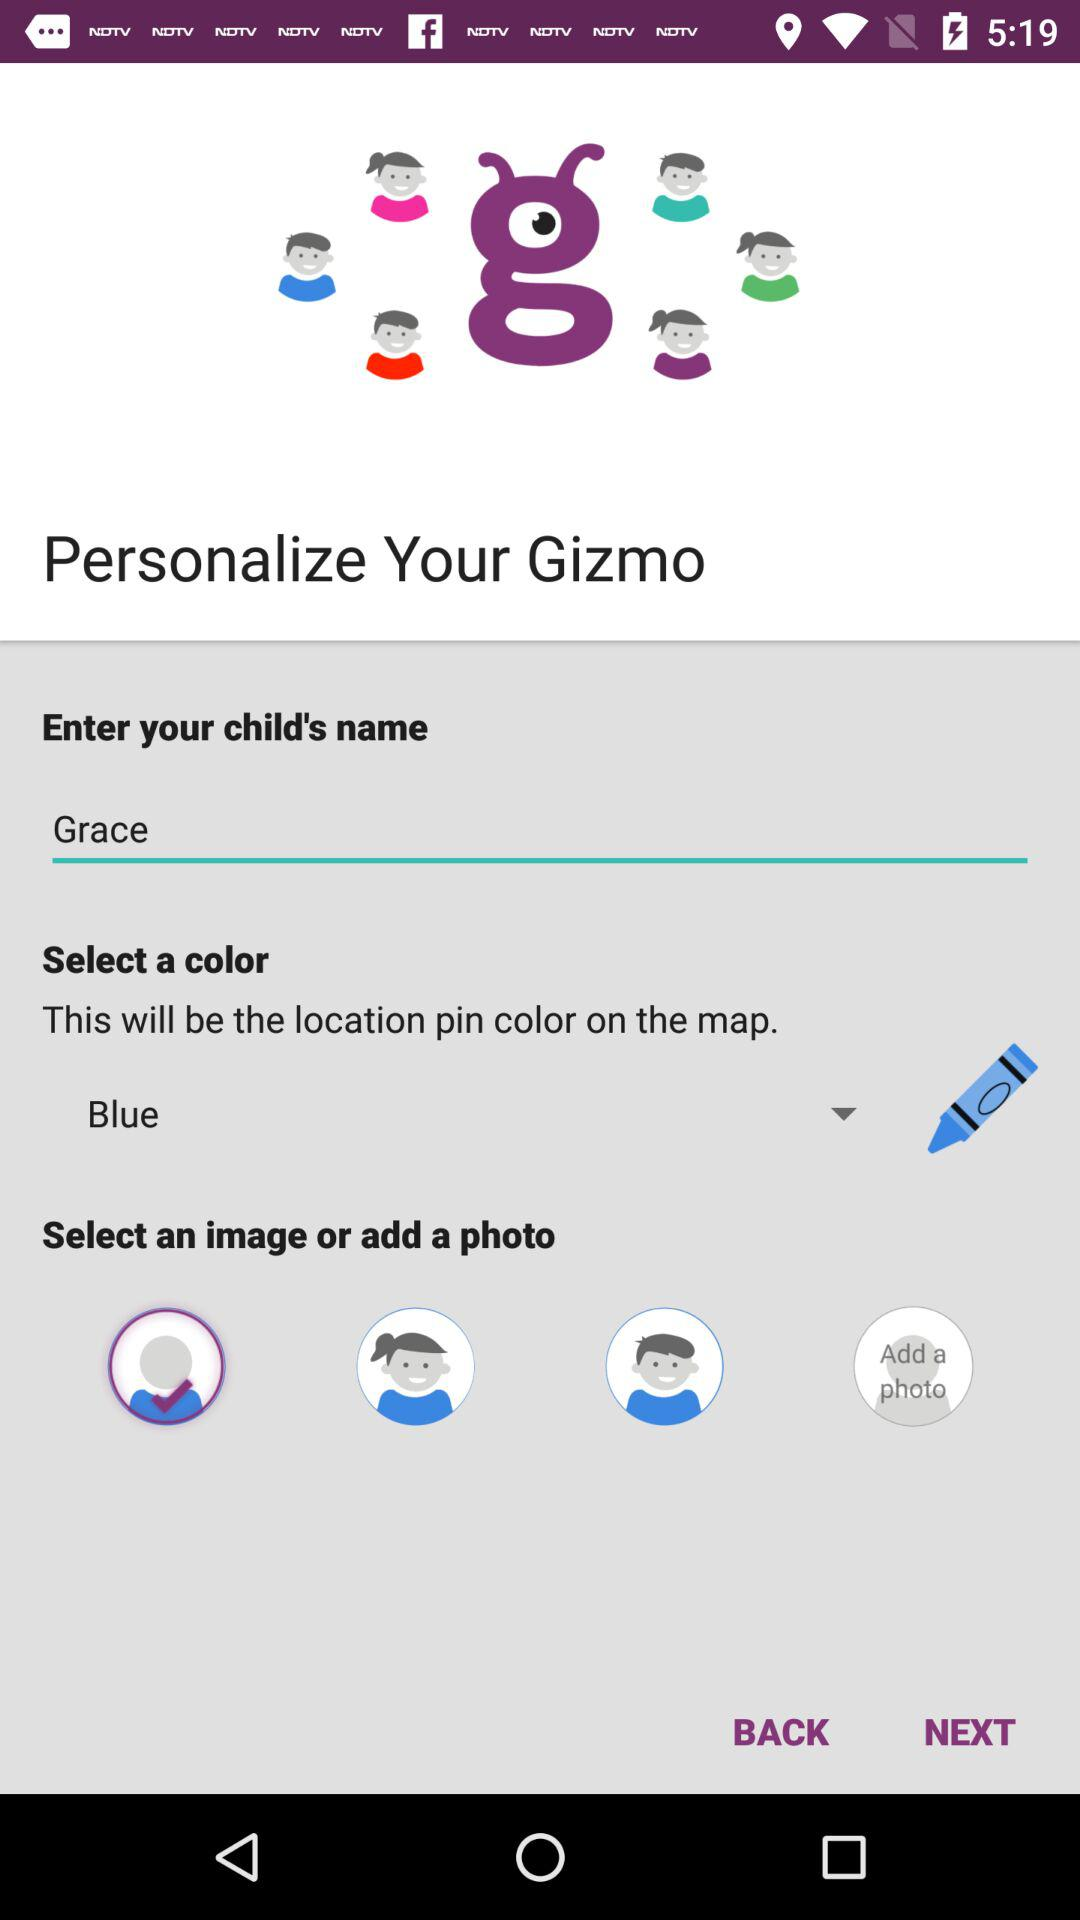Is Grace a male or female?
When the provided information is insufficient, respond with <no answer>. <no answer> 